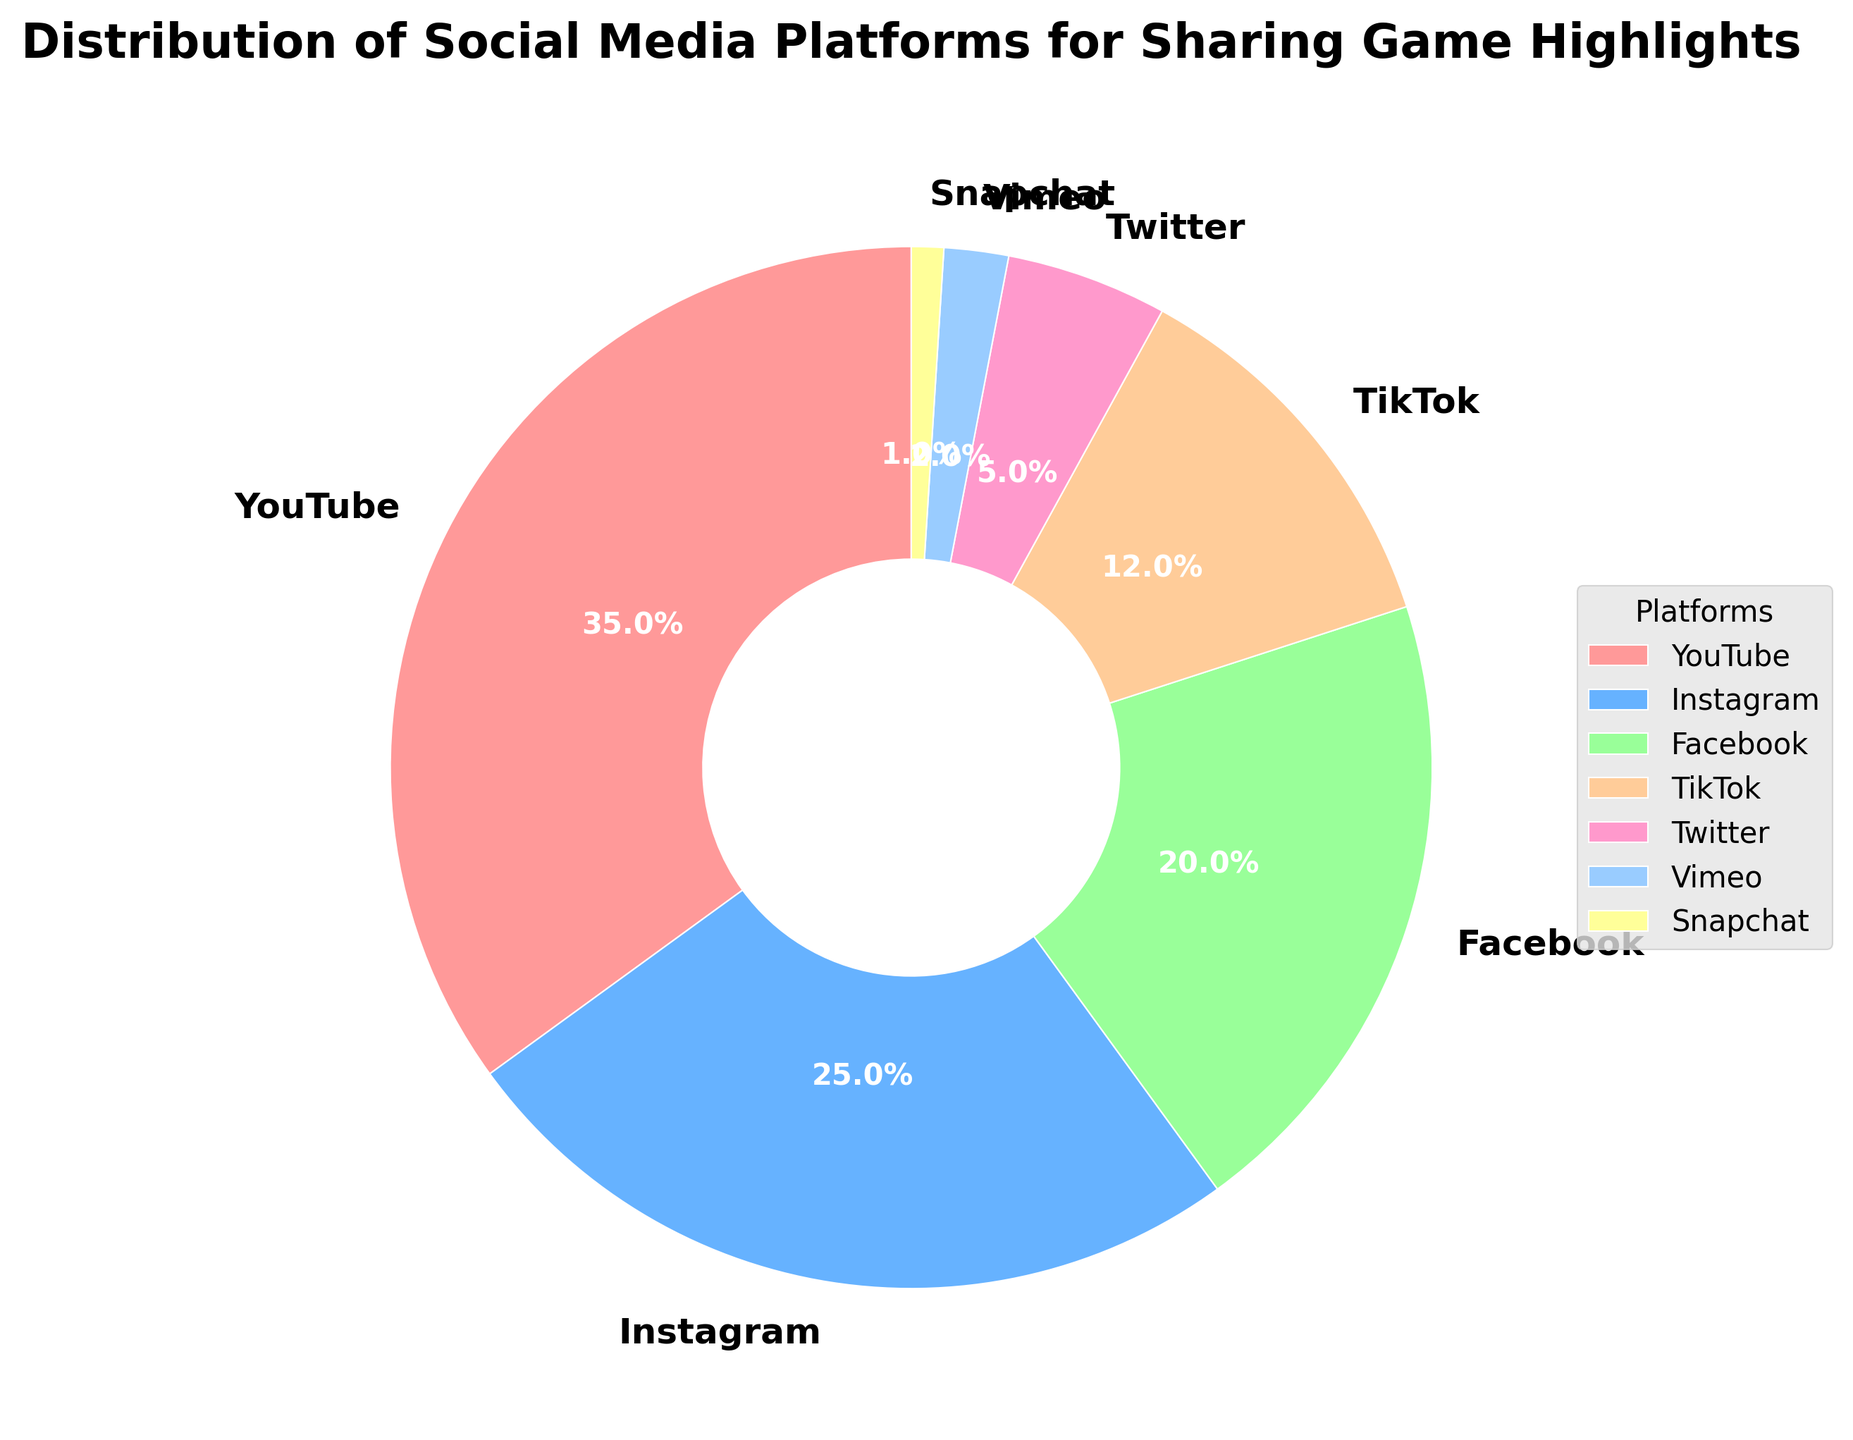What is the most used platform for sharing game highlights? The platform with the largest percentage slice in the pie chart is YouTube. Its slice looks the largest compared to the others and has a label showing 35%.
Answer: YouTube Which platform is the least used for sharing game highlights? The platform with the smallest percentage slice in the pie chart is Snapchat. Its slice is the smallest and has a label showing 1%.
Answer: Snapchat How much more frequently is YouTube used compared to Twitter? YouTube's usage is 35% and Twitter's usage is 5%. The difference is 35% - 5% = 30%.
Answer: 30% If you combine the percentages of Instagram and TikTok, does it exceed YouTube's usage? Instagram is 25% and TikTok is 12%. Combined, they are 25% + 12% = 37%, which is greater than YouTube's 35%.
Answer: Yes What percentage of users prefer Facebook over Vimeo? Facebook has a percentage of 20% and Vimeo has 2%. So, the difference is 20% - 2% = 18%.
Answer: 18% Which platforms together make up exactly half of the total usage? YouTube (35%) and Instagram (25%) together make up 35% + 25% = 60%, thus we need to look at smaller combinations. Facebook (20%) and Instagram (25%) make up 20% + 25% = 45%. Adding TikTok (12%) makes it 45% + 12% = 57%. Hence, YouTube (35%) and TikTok (12%) together make 35% + 12% = 47%, which is close. But, none of the pairs exactly add up to exactly 50%.
Answer: None What is the average percentage usage of the platforms? The percentages are: 35, 25, 20, 12, 5, 2, 1. The sum is 35 + 25 + 20 + 12 + 5 + 2 + 1 = 100%. There are 7 platforms, so the average is 100/7 ≈ 14.29%.
Answer: 14.29% By how much does Instagram's usage exceed the combined usage of Snapchat and Vimeo? Instagram is at 25%, and Snapchat and Vimeo together are 1% + 2% = 3%. The difference is 25% - 3% = 22%.
Answer: 22% Which platforms have usage percentages less than 10%? The platforms with usage percentages less than 10% are Twitter (5%), Vimeo (2%), and Snapchat (1%).
Answer: Twitter, Vimeo, Snapchat What percentage of usage is covered by the top three platforms combined? The top three platforms by percentage are YouTube (35%), Instagram (25%), and Facebook (20%). Combined, they are 35% + 25% + 20% = 80%.
Answer: 80% 